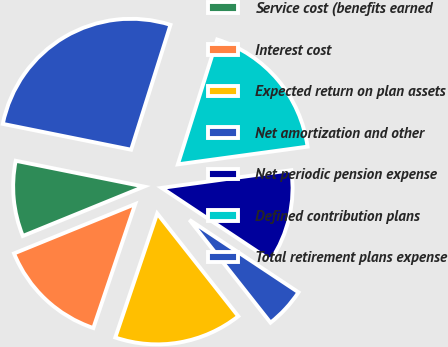Convert chart to OTSL. <chart><loc_0><loc_0><loc_500><loc_500><pie_chart><fcel>Service cost (benefits earned<fcel>Interest cost<fcel>Expected return on plan assets<fcel>Net amortization and other<fcel>Net periodic pension expense<fcel>Defined contribution plans<fcel>Total retirement plans expense<nl><fcel>9.32%<fcel>13.65%<fcel>15.82%<fcel>5.04%<fcel>11.49%<fcel>17.98%<fcel>26.7%<nl></chart> 